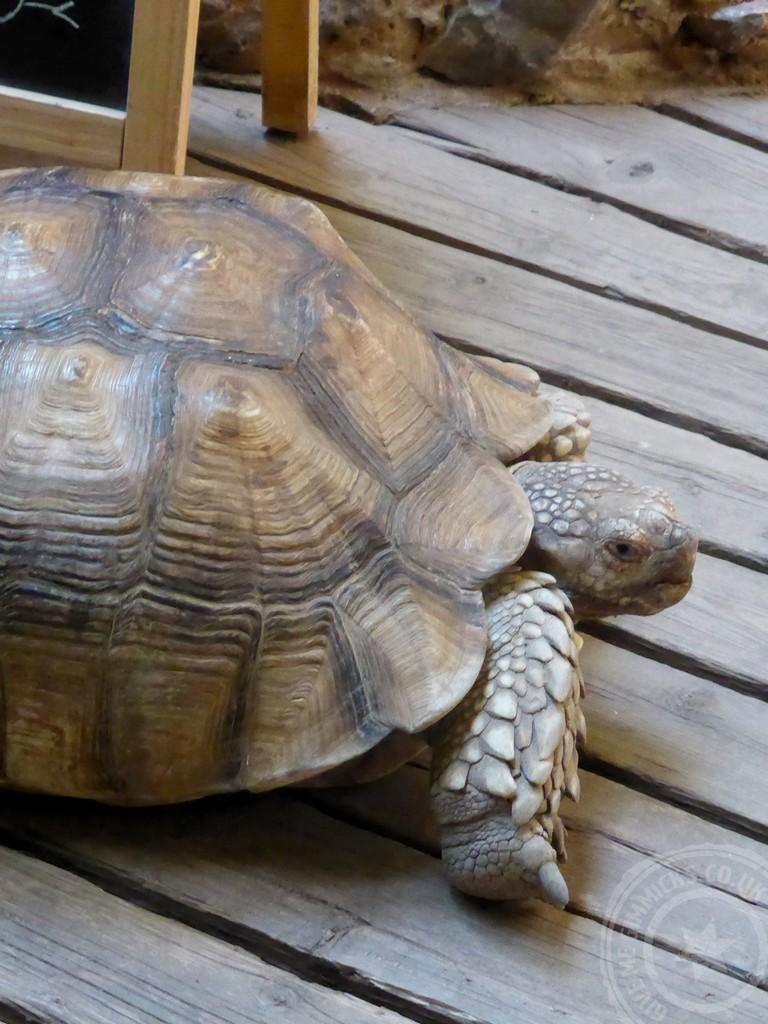What type of surface is visible in the image? There is a wooden surface in the image. What animal can be seen on the wooden surface? A tortoise is present on the wooden surface. In which direction is the tortoise facing? The tortoise is facing towards the right side of the image. What type of wax can be seen melting on the wooden surface in the image? There is no wax present in the image; it only features a tortoise on a wooden surface. 